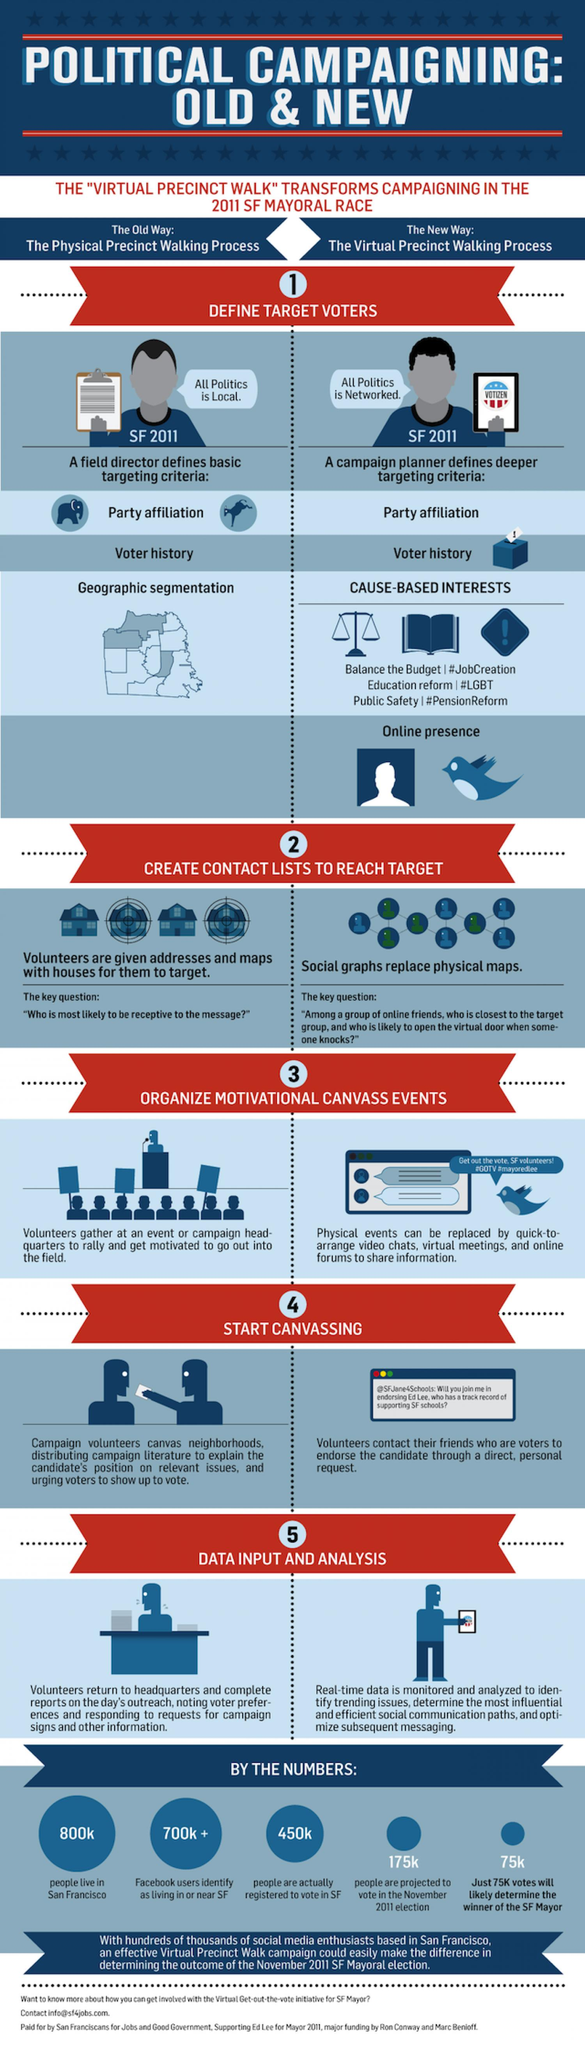Draw attention to some important aspects in this diagram. The voter history is now captured in a new way through cause-based interests, which provides a more comprehensive and accurate representation of a user's interests and preferences. The voter history is traditionally captured through geographic segmentation, which involves dividing a given area into distinct segments based on geographic characteristics such as census tracts, zip codes, or political districts. The term 'virtual precinct walking' refers to a new method of campaigning that involves utilizing virtual means to engage with constituents and gather information. The term 'the physical precinct walking process,' also known as the old way, refers to the process of physically visiting and walking through a designated area or precinct in order to collect data or perform a task. Approximately 700,000 Facebook users in the San Francisco Bay Area have identified themselves as residing in or near the city of San Francisco. 